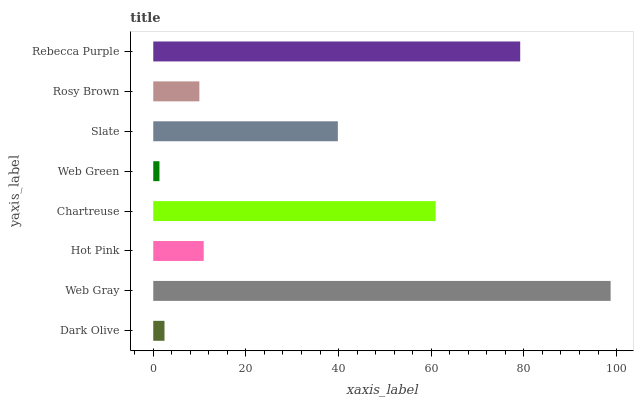Is Web Green the minimum?
Answer yes or no. Yes. Is Web Gray the maximum?
Answer yes or no. Yes. Is Hot Pink the minimum?
Answer yes or no. No. Is Hot Pink the maximum?
Answer yes or no. No. Is Web Gray greater than Hot Pink?
Answer yes or no. Yes. Is Hot Pink less than Web Gray?
Answer yes or no. Yes. Is Hot Pink greater than Web Gray?
Answer yes or no. No. Is Web Gray less than Hot Pink?
Answer yes or no. No. Is Slate the high median?
Answer yes or no. Yes. Is Hot Pink the low median?
Answer yes or no. Yes. Is Chartreuse the high median?
Answer yes or no. No. Is Chartreuse the low median?
Answer yes or no. No. 